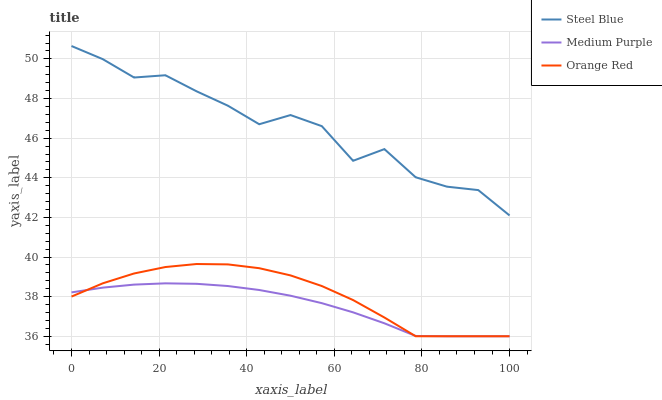Does Medium Purple have the minimum area under the curve?
Answer yes or no. Yes. Does Steel Blue have the maximum area under the curve?
Answer yes or no. Yes. Does Orange Red have the minimum area under the curve?
Answer yes or no. No. Does Orange Red have the maximum area under the curve?
Answer yes or no. No. Is Medium Purple the smoothest?
Answer yes or no. Yes. Is Steel Blue the roughest?
Answer yes or no. Yes. Is Orange Red the smoothest?
Answer yes or no. No. Is Orange Red the roughest?
Answer yes or no. No. Does Steel Blue have the lowest value?
Answer yes or no. No. Does Orange Red have the highest value?
Answer yes or no. No. Is Orange Red less than Steel Blue?
Answer yes or no. Yes. Is Steel Blue greater than Medium Purple?
Answer yes or no. Yes. Does Orange Red intersect Steel Blue?
Answer yes or no. No. 